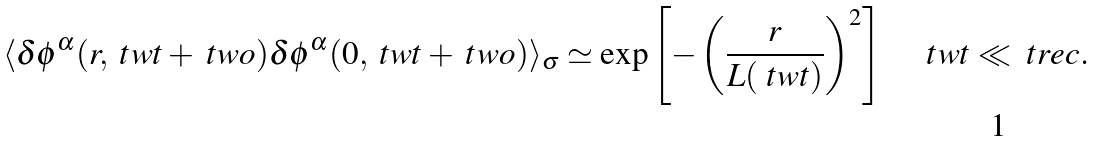<formula> <loc_0><loc_0><loc_500><loc_500>\langle \delta \phi ^ { \alpha } ( r , \ t w t + \ t w o ) \delta \phi ^ { \alpha } ( 0 , \ t w t + \ t w o ) \rangle _ { \sigma } \simeq \exp \left [ - \left ( \frac { r } { L ( \ t w t ) } \right ) ^ { 2 } \right ] \quad \ t w t \ll \ t r e c .</formula> 